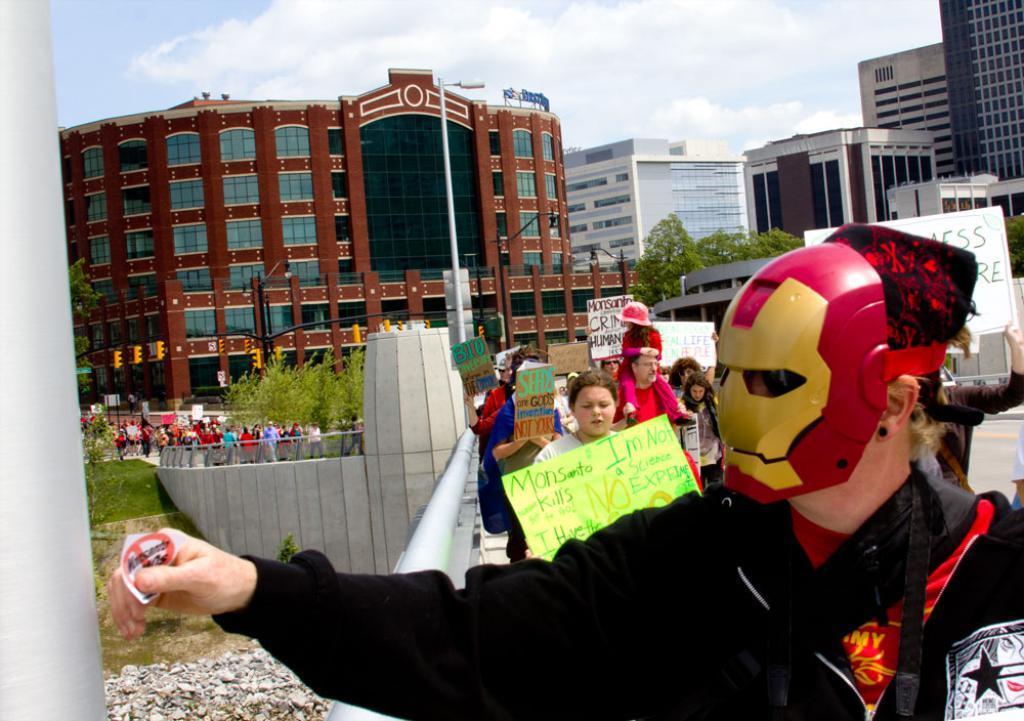How would you summarize this image in a sentence or two? In this picture we can observe some people standing, holding charts in their hands. On the right side we can observe a person wearing a mask on his face. In the background there are buildings trees and a sky with some clouds. 